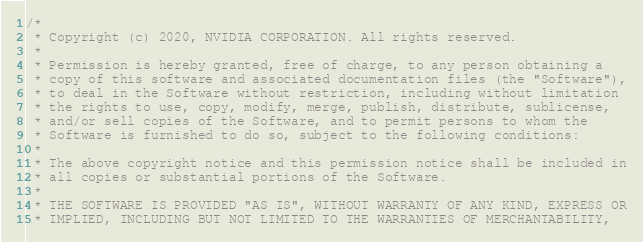<code> <loc_0><loc_0><loc_500><loc_500><_C++_>/*
 * Copyright (c) 2020, NVIDIA CORPORATION. All rights reserved.
 *
 * Permission is hereby granted, free of charge, to any person obtaining a
 * copy of this software and associated documentation files (the "Software"),
 * to deal in the Software without restriction, including without limitation
 * the rights to use, copy, modify, merge, publish, distribute, sublicense,
 * and/or sell copies of the Software, and to permit persons to whom the
 * Software is furnished to do so, subject to the following conditions:
 *
 * The above copyright notice and this permission notice shall be included in
 * all copies or substantial portions of the Software.
 *
 * THE SOFTWARE IS PROVIDED "AS IS", WITHOUT WARRANTY OF ANY KIND, EXPRESS OR
 * IMPLIED, INCLUDING BUT NOT LIMITED TO THE WARRANTIES OF MERCHANTABILITY,</code> 